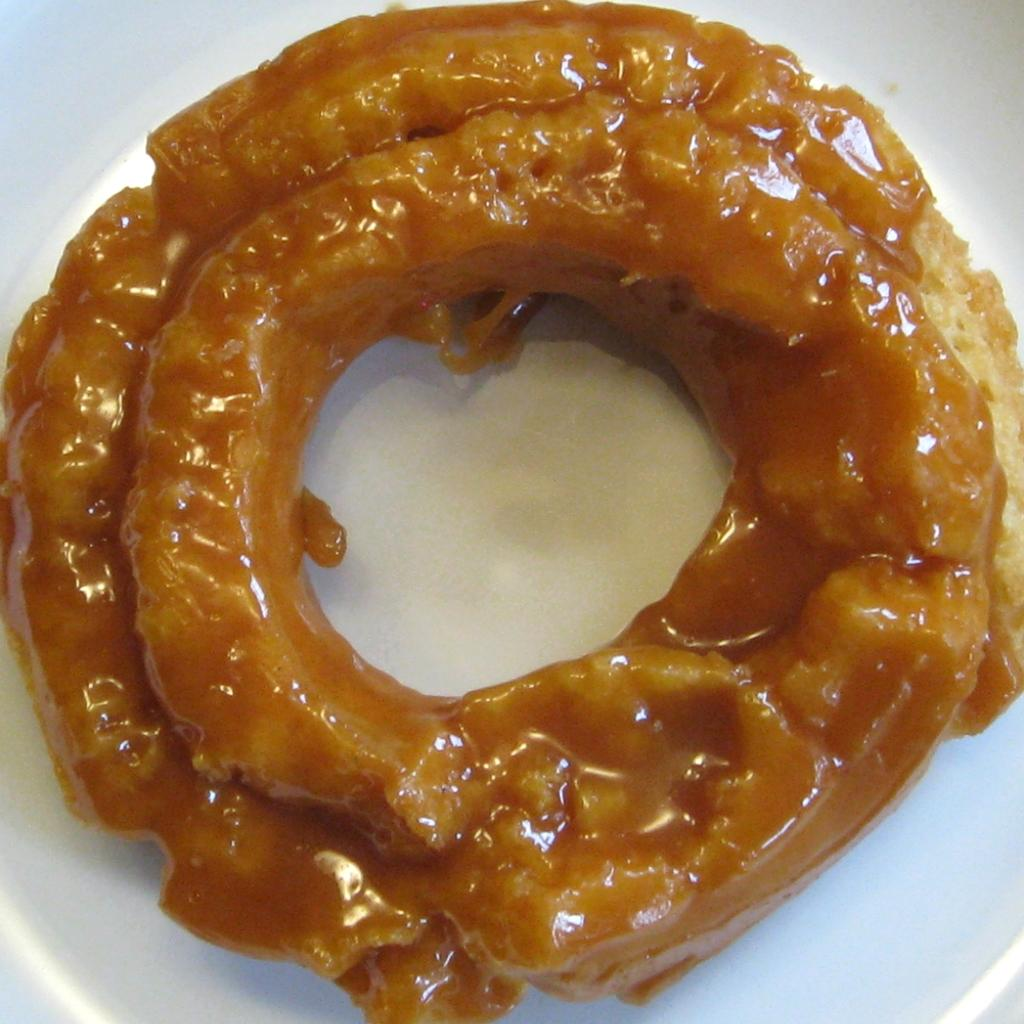What is on the plate that is visible in the image? The plate contains edible items. What can be seen in the background of the image? The background of the image is white in color. What type of bridge can be seen in the image? There is no bridge present in the image. What copper detail is visible on the plate in the image? There is no copper detail present on the plate in the image. 